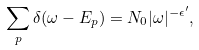Convert formula to latex. <formula><loc_0><loc_0><loc_500><loc_500>\sum _ { p } \delta ( \omega - E _ { p } ) = N _ { 0 } | \omega | ^ { - \epsilon ^ { \prime } } ,</formula> 